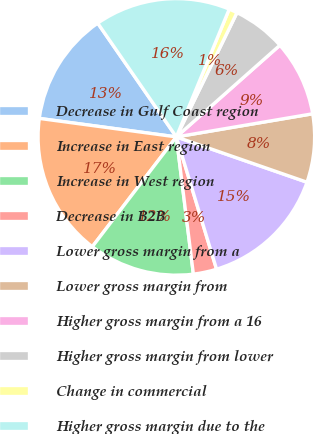Convert chart. <chart><loc_0><loc_0><loc_500><loc_500><pie_chart><fcel>Decrease in Gulf Coast region<fcel>Increase in East region<fcel>Increase in West region<fcel>Decrease in B2B<fcel>Lower gross margin from a<fcel>Lower gross margin from<fcel>Higher gross margin from a 16<fcel>Higher gross margin from lower<fcel>Change in commercial<fcel>Higher gross margin due to the<nl><fcel>13.24%<fcel>16.74%<fcel>12.36%<fcel>2.73%<fcel>14.99%<fcel>7.99%<fcel>8.86%<fcel>6.24%<fcel>0.98%<fcel>15.87%<nl></chart> 